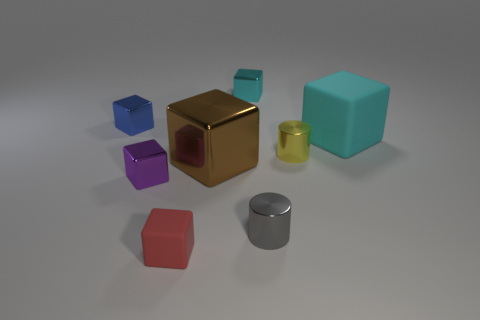Is there any other thing that is the same color as the tiny rubber block?
Your response must be concise. No. Is the tiny yellow shiny object the same shape as the large brown thing?
Your response must be concise. No. What size is the rubber block in front of the cube on the right side of the small metallic block behind the tiny blue thing?
Ensure brevity in your answer.  Small. How many other objects are the same material as the small blue object?
Make the answer very short. 5. The big thing that is left of the big cyan object is what color?
Provide a succinct answer. Brown. What is the material of the cyan thing in front of the tiny blue shiny object that is left of the brown shiny block in front of the blue shiny object?
Give a very brief answer. Rubber. Are there any other small objects that have the same shape as the small blue thing?
Provide a short and direct response. Yes. What shape is the yellow object that is the same size as the purple object?
Your response must be concise. Cylinder. How many shiny cubes are both behind the cyan rubber cube and left of the red cube?
Your answer should be compact. 1. Is the number of large brown metallic cubes that are right of the purple cube less than the number of shiny blocks?
Give a very brief answer. Yes. 